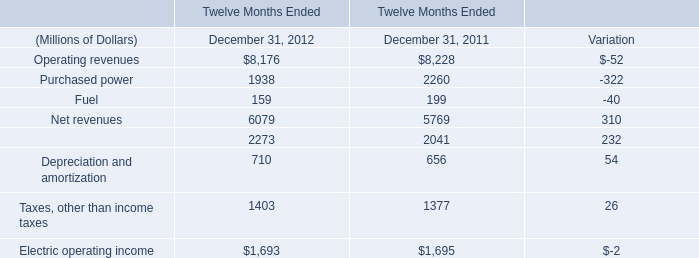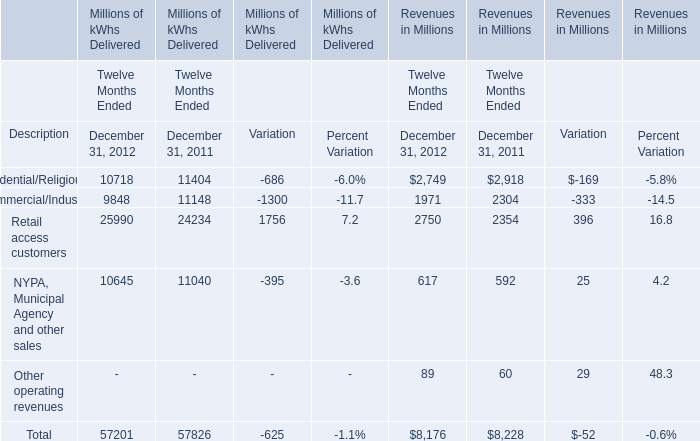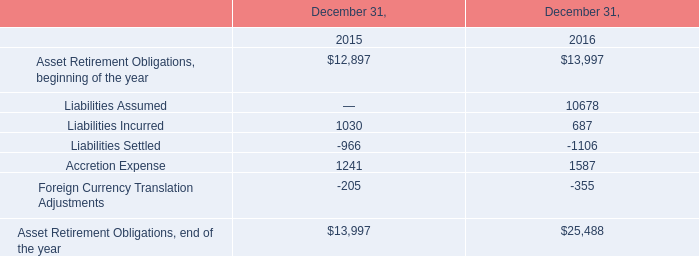What was the total amount of the Fuel in the years where Operating revenues is greater than 8000? (in million) 
Computations: (159 + 199)
Answer: 358.0. 